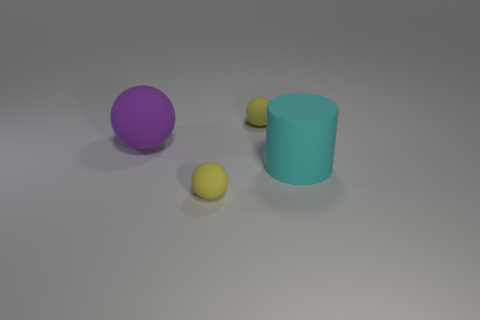Add 4 small yellow objects. How many objects exist? 8 Subtract all balls. How many objects are left? 1 Subtract all tiny cyan shiny spheres. Subtract all purple matte balls. How many objects are left? 3 Add 2 large things. How many large things are left? 4 Add 2 brown metal things. How many brown metal things exist? 2 Subtract 0 brown balls. How many objects are left? 4 